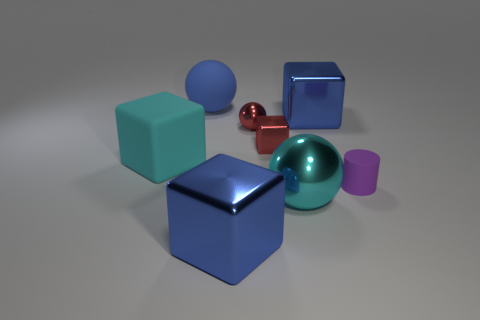What number of cylinders are either big blue matte things or big cyan rubber things? 0 